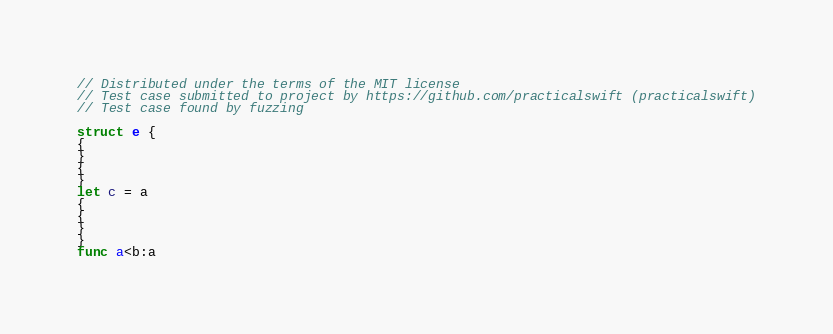<code> <loc_0><loc_0><loc_500><loc_500><_Swift_>// Distributed under the terms of the MIT license
// Test case submitted to project by https://github.com/practicalswift (practicalswift)
// Test case found by fuzzing

struct e {
{
}
{
}
let c = a
{
{
}
}
func a<b:a
</code> 